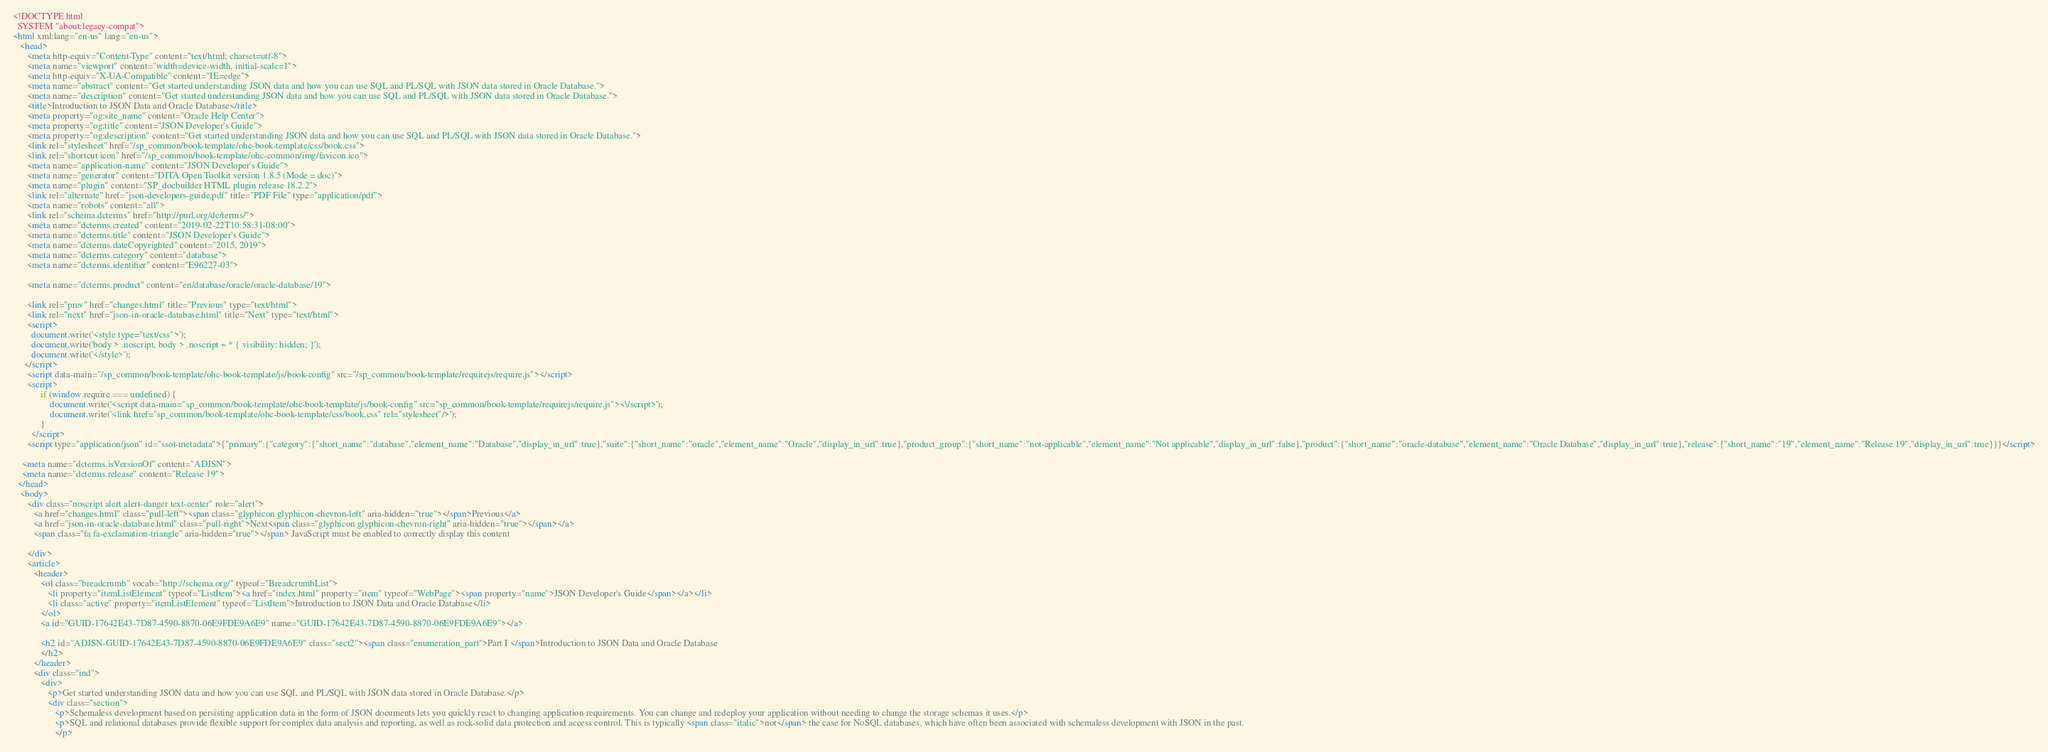Convert code to text. <code><loc_0><loc_0><loc_500><loc_500><_HTML_><!DOCTYPE html
  SYSTEM "about:legacy-compat">
<html xml:lang="en-us" lang="en-us">
   <head>
      <meta http-equiv="Content-Type" content="text/html; charset=utf-8">
      <meta name="viewport" content="width=device-width, initial-scale=1">
      <meta http-equiv="X-UA-Compatible" content="IE=edge">
      <meta name="abstract" content="Get started understanding JSON data and how you can use SQL and PL/SQL with JSON data stored in Oracle Database.">
      <meta name="description" content="Get started understanding JSON data and how you can use SQL and PL/SQL with JSON data stored in Oracle Database.">
      <title>Introduction to JSON Data and Oracle Database</title>
      <meta property="og:site_name" content="Oracle Help Center">
      <meta property="og:title" content="JSON Developer's Guide">
      <meta property="og:description" content="Get started understanding JSON data and how you can use SQL and PL/SQL with JSON data stored in Oracle Database.">
      <link rel="stylesheet" href="/sp_common/book-template/ohc-book-template/css/book.css">
      <link rel="shortcut icon" href="/sp_common/book-template/ohc-common/img/favicon.ico">
      <meta name="application-name" content="JSON Developer's Guide">
      <meta name="generator" content="DITA Open Toolkit version 1.8.5 (Mode = doc)">
      <meta name="plugin" content="SP_docbuilder HTML plugin release 18.2.2">
      <link rel="alternate" href="json-developers-guide.pdf" title="PDF File" type="application/pdf">
      <meta name="robots" content="all">
      <link rel="schema.dcterms" href="http://purl.org/dc/terms/">
      <meta name="dcterms.created" content="2019-02-22T10:58:31-08:00">
      <meta name="dcterms.title" content="JSON Developer's Guide">
      <meta name="dcterms.dateCopyrighted" content="2015, 2019">
      <meta name="dcterms.category" content="database">
      <meta name="dcterms.identifier" content="E96227-03">
      
      <meta name="dcterms.product" content="en/database/oracle/oracle-database/19">
      
      <link rel="prev" href="changes.html" title="Previous" type="text/html">
      <link rel="next" href="json-in-oracle-database.html" title="Next" type="text/html">
      <script>
        document.write('<style type="text/css">');
        document.write('body > .noscript, body > .noscript ~ * { visibility: hidden; }');
        document.write('</style>');
     </script>
      <script data-main="/sp_common/book-template/ohc-book-template/js/book-config" src="/sp_common/book-template/requirejs/require.js"></script>
      <script>
            if (window.require === undefined) {
                document.write('<script data-main="sp_common/book-template/ohc-book-template/js/book-config" src="sp_common/book-template/requirejs/require.js"><\/script>');
                document.write('<link href="sp_common/book-template/ohc-book-template/css/book.css" rel="stylesheet"/>');
            }
        </script>
      <script type="application/json" id="ssot-metadata">{"primary":{"category":{"short_name":"database","element_name":"Database","display_in_url":true},"suite":{"short_name":"oracle","element_name":"Oracle","display_in_url":true},"product_group":{"short_name":"not-applicable","element_name":"Not applicable","display_in_url":false},"product":{"short_name":"oracle-database","element_name":"Oracle Database","display_in_url":true},"release":{"short_name":"19","element_name":"Release 19","display_in_url":true}}}</script>
      
    <meta name="dcterms.isVersionOf" content="ADJSN">
    <meta name="dcterms.release" content="Release 19">
  </head>
   <body>
      <div class="noscript alert alert-danger text-center" role="alert">
         <a href="changes.html" class="pull-left"><span class="glyphicon glyphicon-chevron-left" aria-hidden="true"></span>Previous</a>
         <a href="json-in-oracle-database.html" class="pull-right">Next<span class="glyphicon glyphicon-chevron-right" aria-hidden="true"></span></a>
         <span class="fa fa-exclamation-triangle" aria-hidden="true"></span> JavaScript must be enabled to correctly display this content
        
      </div>
      <article>
         <header>
            <ol class="breadcrumb" vocab="http://schema.org/" typeof="BreadcrumbList">
               <li property="itemListElement" typeof="ListItem"><a href="index.html" property="item" typeof="WebPage"><span property="name">JSON Developer's Guide</span></a></li>
               <li class="active" property="itemListElement" typeof="ListItem">Introduction to JSON Data and Oracle Database</li>
            </ol>
            <a id="GUID-17642E43-7D87-4590-8870-06E9FDE9A6E9" name="GUID-17642E43-7D87-4590-8870-06E9FDE9A6E9"></a>
            
            <h2 id="ADJSN-GUID-17642E43-7D87-4590-8870-06E9FDE9A6E9" class="sect2"><span class="enumeration_part">Part I </span>Introduction to JSON Data and Oracle Database
            </h2>
         </header>
         <div class="ind">
            <div>
               <p>Get started understanding JSON data and how you can use SQL and PL/SQL with JSON data stored in Oracle Database.</p>
               <div class="section">
                  <p>Schemaless development based on persisting application data in the form of JSON documents lets you quickly react to changing application requirements. You can change and redeploy your application without needing to change the storage schemas it uses.</p>
                  <p>SQL and relational databases provide flexible support for complex data analysis and reporting, as well as rock-solid data protection and access control. This is typically <span class="italic">not</span> the case for NoSQL databases, which have often been associated with schemaless development with JSON in the past.
                  </p></code> 